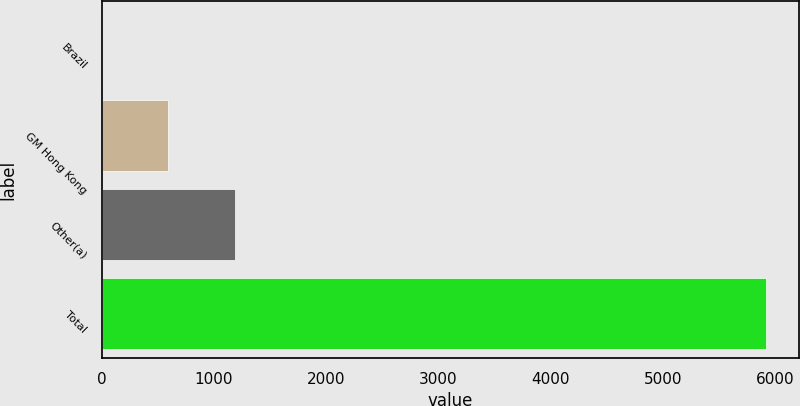Convert chart to OTSL. <chart><loc_0><loc_0><loc_500><loc_500><bar_chart><fcel>Brazil<fcel>GM Hong Kong<fcel>Other(a)<fcel>Total<nl><fcel>2<fcel>593.7<fcel>1185.4<fcel>5919<nl></chart> 